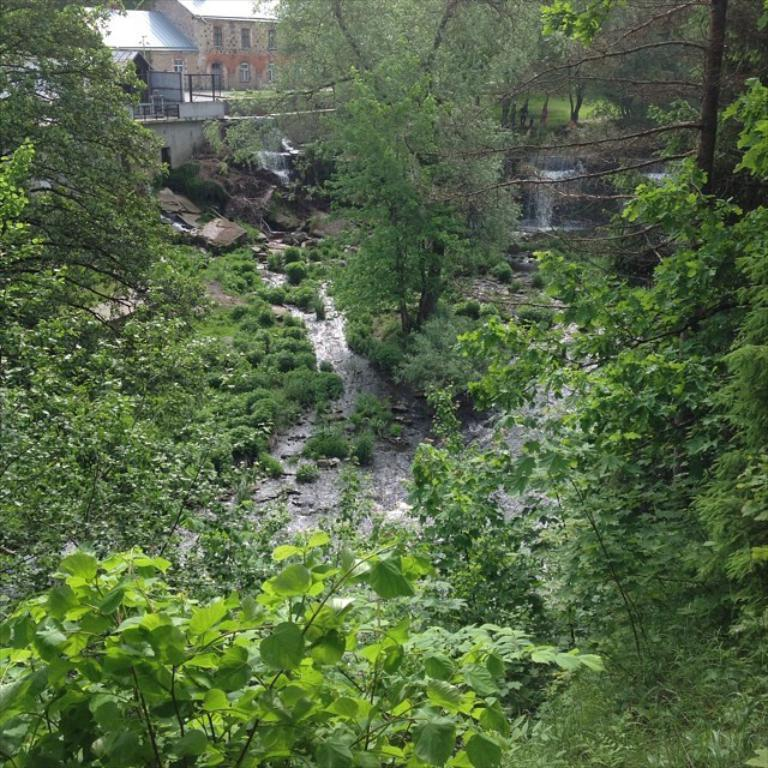What type of natural elements can be seen in the image? There are trees and water visible in the image. What other objects or features can be seen in the image? There are rocks and a building in the image. What type of noise can be heard coming from the cow in the image? There is no cow present in the image, so it is not possible to determine what noise might be heard. 